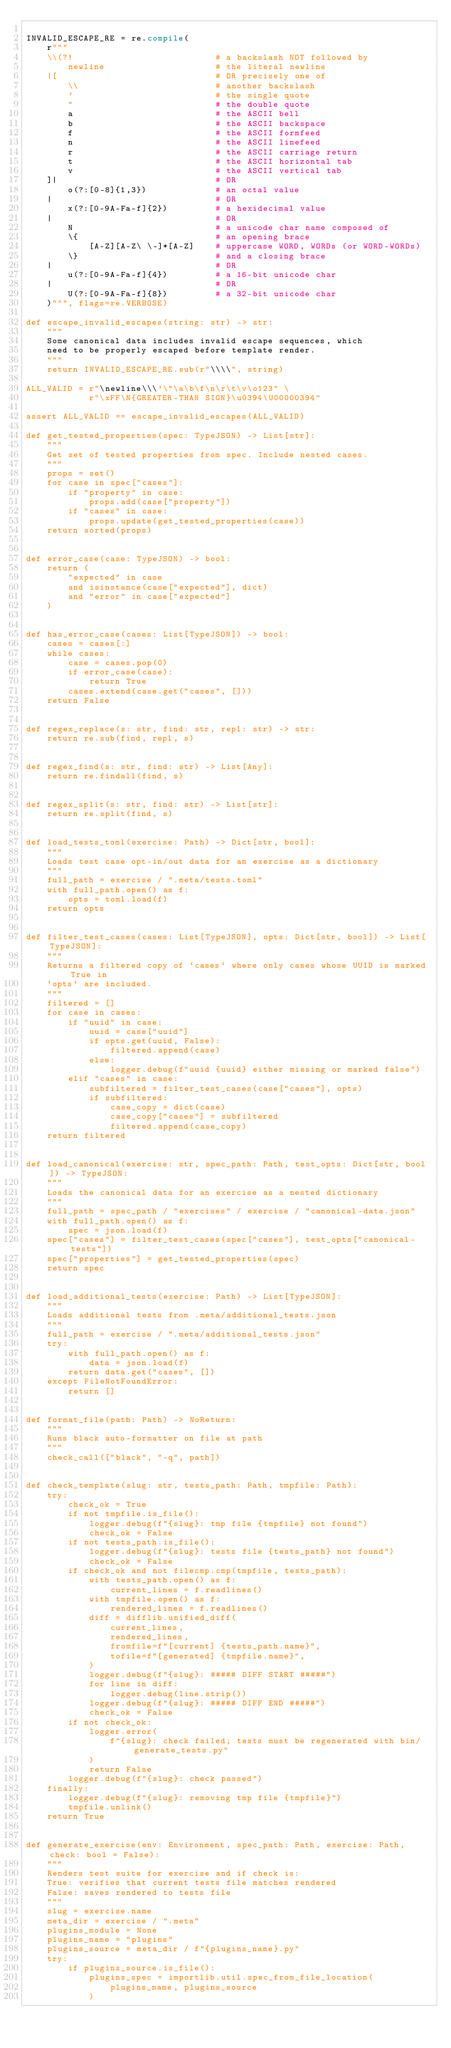<code> <loc_0><loc_0><loc_500><loc_500><_Python_>
INVALID_ESCAPE_RE = re.compile(
    r"""
    \\(?!                           # a backslash NOT followed by
        newline                     # the literal newline
    |[                              # OR precisely one of
        \\                          # another backslash
        '                           # the single quote
        "                           # the double quote
        a                           # the ASCII bell
        b                           # the ASCII backspace
        f                           # the ASCII formfeed
        n                           # the ASCII linefeed
        r                           # the ASCII carriage return
        t                           # the ASCII horizontal tab
        v                           # the ASCII vertical tab
    ]|                              # OR
        o(?:[0-8]{1,3})             # an octal value
    |                               # OR
        x(?:[0-9A-Fa-f]{2})         # a hexidecimal value
    |                               # OR
        N                           # a unicode char name composed of
        \{                          # an opening brace
            [A-Z][A-Z\ \-]*[A-Z]    # uppercase WORD, WORDs (or WORD-WORDs)
        \}                          # and a closing brace
    |                               # OR
        u(?:[0-9A-Fa-f]{4})         # a 16-bit unicode char
    |                               # OR
        U(?:[0-9A-Fa-f]{8})         # a 32-bit unicode char
    )""", flags=re.VERBOSE)

def escape_invalid_escapes(string: str) -> str:
    """
    Some canonical data includes invalid escape sequences, which
    need to be properly escaped before template render.
    """
    return INVALID_ESCAPE_RE.sub(r"\\\\", string)

ALL_VALID = r"\newline\\\'\"\a\b\f\n\r\t\v\o123" \
            r"\xFF\N{GREATER-THAN SIGN}\u0394\U00000394"

assert ALL_VALID == escape_invalid_escapes(ALL_VALID)

def get_tested_properties(spec: TypeJSON) -> List[str]:
    """
    Get set of tested properties from spec. Include nested cases.
    """
    props = set()
    for case in spec["cases"]:
        if "property" in case:
            props.add(case["property"])
        if "cases" in case:
            props.update(get_tested_properties(case))
    return sorted(props)


def error_case(case: TypeJSON) -> bool:
    return (
        "expected" in case
        and isinstance(case["expected"], dict)
        and "error" in case["expected"]
    )


def has_error_case(cases: List[TypeJSON]) -> bool:
    cases = cases[:]
    while cases:
        case = cases.pop(0)
        if error_case(case):
            return True
        cases.extend(case.get("cases", []))
    return False


def regex_replace(s: str, find: str, repl: str) -> str:
    return re.sub(find, repl, s)


def regex_find(s: str, find: str) -> List[Any]:
    return re.findall(find, s)


def regex_split(s: str, find: str) -> List[str]:
    return re.split(find, s)


def load_tests_toml(exercise: Path) -> Dict[str, bool]:
    """
    Loads test case opt-in/out data for an exercise as a dictionary
    """
    full_path = exercise / ".meta/tests.toml"
    with full_path.open() as f:
        opts = toml.load(f)
    return opts


def filter_test_cases(cases: List[TypeJSON], opts: Dict[str, bool]) -> List[TypeJSON]:
    """
    Returns a filtered copy of `cases` where only cases whose UUID is marked True in
    `opts` are included.
    """
    filtered = []
    for case in cases:
        if "uuid" in case:
            uuid = case["uuid"]
            if opts.get(uuid, False):
                filtered.append(case)
            else:
                logger.debug(f"uuid {uuid} either missing or marked false")
        elif "cases" in case:
            subfiltered = filter_test_cases(case["cases"], opts)
            if subfiltered:
                case_copy = dict(case)
                case_copy["cases"] = subfiltered
                filtered.append(case_copy)
    return filtered


def load_canonical(exercise: str, spec_path: Path, test_opts: Dict[str, bool]) -> TypeJSON:
    """
    Loads the canonical data for an exercise as a nested dictionary
    """
    full_path = spec_path / "exercises" / exercise / "canonical-data.json"
    with full_path.open() as f:
        spec = json.load(f)
    spec["cases"] = filter_test_cases(spec["cases"], test_opts["canonical-tests"])
    spec["properties"] = get_tested_properties(spec)
    return spec


def load_additional_tests(exercise: Path) -> List[TypeJSON]:
    """
    Loads additional tests from .meta/additional_tests.json
    """
    full_path = exercise / ".meta/additional_tests.json"
    try:
        with full_path.open() as f:
            data = json.load(f)
        return data.get("cases", [])
    except FileNotFoundError:
        return []


def format_file(path: Path) -> NoReturn:
    """
    Runs black auto-formatter on file at path
    """
    check_call(["black", "-q", path])


def check_template(slug: str, tests_path: Path, tmpfile: Path):
    try:
        check_ok = True
        if not tmpfile.is_file():
            logger.debug(f"{slug}: tmp file {tmpfile} not found")
            check_ok = False
        if not tests_path.is_file():
            logger.debug(f"{slug}: tests file {tests_path} not found")
            check_ok = False
        if check_ok and not filecmp.cmp(tmpfile, tests_path):
            with tests_path.open() as f:
                current_lines = f.readlines()
            with tmpfile.open() as f:
                rendered_lines = f.readlines()
            diff = difflib.unified_diff(
                current_lines,
                rendered_lines,
                fromfile=f"[current] {tests_path.name}",
                tofile=f"[generated] {tmpfile.name}",
            )
            logger.debug(f"{slug}: ##### DIFF START #####")
            for line in diff:
                logger.debug(line.strip())
            logger.debug(f"{slug}: ##### DIFF END #####")
            check_ok = False
        if not check_ok:
            logger.error(
                f"{slug}: check failed; tests must be regenerated with bin/generate_tests.py"
            )
            return False
        logger.debug(f"{slug}: check passed")
    finally:
        logger.debug(f"{slug}: removing tmp file {tmpfile}")
        tmpfile.unlink()
    return True


def generate_exercise(env: Environment, spec_path: Path, exercise: Path, check: bool = False):
    """
    Renders test suite for exercise and if check is:
    True: verifies that current tests file matches rendered
    False: saves rendered to tests file
    """
    slug = exercise.name
    meta_dir = exercise / ".meta"
    plugins_module = None
    plugins_name = "plugins"
    plugins_source = meta_dir / f"{plugins_name}.py"
    try:
        if plugins_source.is_file():
            plugins_spec = importlib.util.spec_from_file_location(
                plugins_name, plugins_source
            )</code> 